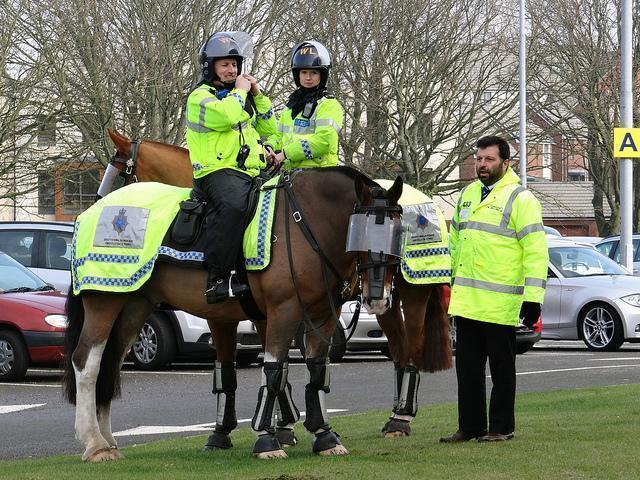What are they preparing for?
Indicate the correct choice and explain in the format: 'Answer: answer
Rationale: rationale.'
Options: Parade, war, riot, fashion show. Answer: riot.
Rationale: They look to be preparing for a parade to ride their horses in or guide traffic. 